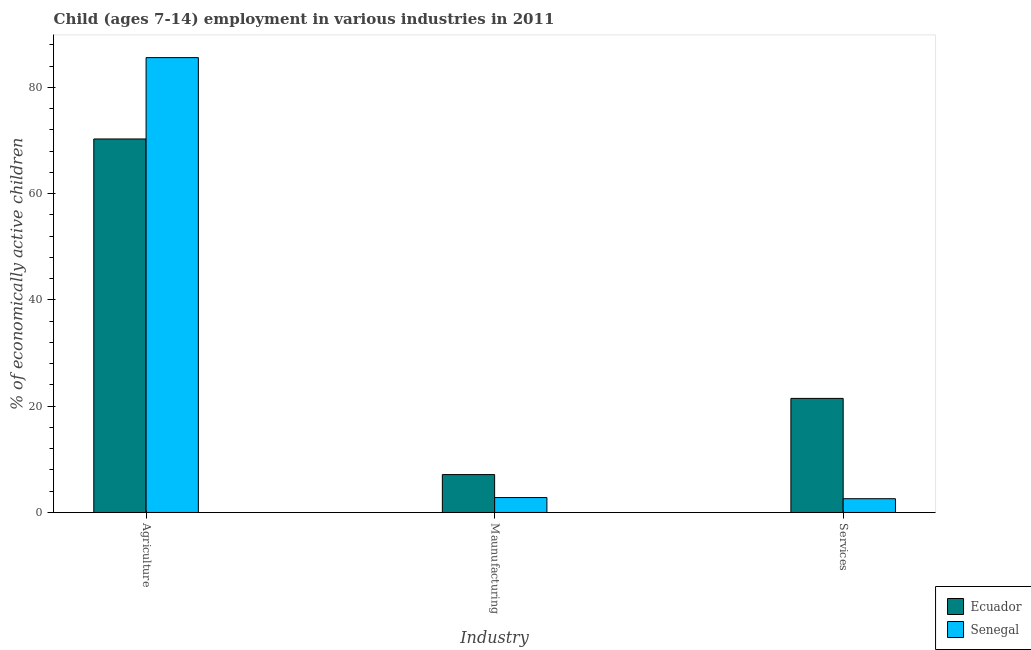How many different coloured bars are there?
Offer a very short reply. 2. Are the number of bars per tick equal to the number of legend labels?
Offer a terse response. Yes. Are the number of bars on each tick of the X-axis equal?
Give a very brief answer. Yes. How many bars are there on the 3rd tick from the right?
Offer a very short reply. 2. What is the label of the 1st group of bars from the left?
Provide a succinct answer. Agriculture. What is the percentage of economically active children in services in Senegal?
Offer a terse response. 2.59. Across all countries, what is the maximum percentage of economically active children in services?
Keep it short and to the point. 21.47. Across all countries, what is the minimum percentage of economically active children in services?
Offer a very short reply. 2.59. In which country was the percentage of economically active children in manufacturing maximum?
Make the answer very short. Ecuador. In which country was the percentage of economically active children in services minimum?
Provide a succinct answer. Senegal. What is the total percentage of economically active children in manufacturing in the graph?
Your response must be concise. 9.94. What is the difference between the percentage of economically active children in services in Ecuador and that in Senegal?
Offer a terse response. 18.88. What is the difference between the percentage of economically active children in agriculture in Ecuador and the percentage of economically active children in manufacturing in Senegal?
Offer a very short reply. 67.48. What is the average percentage of economically active children in services per country?
Offer a very short reply. 12.03. What is the difference between the percentage of economically active children in services and percentage of economically active children in agriculture in Ecuador?
Offer a terse response. -48.82. In how many countries, is the percentage of economically active children in services greater than 56 %?
Offer a very short reply. 0. What is the ratio of the percentage of economically active children in services in Senegal to that in Ecuador?
Your response must be concise. 0.12. What is the difference between the highest and the second highest percentage of economically active children in services?
Ensure brevity in your answer.  18.88. What is the difference between the highest and the lowest percentage of economically active children in services?
Provide a short and direct response. 18.88. In how many countries, is the percentage of economically active children in services greater than the average percentage of economically active children in services taken over all countries?
Your response must be concise. 1. What does the 2nd bar from the left in Services represents?
Ensure brevity in your answer.  Senegal. What does the 1st bar from the right in Services represents?
Provide a short and direct response. Senegal. How many bars are there?
Offer a terse response. 6. Are all the bars in the graph horizontal?
Your answer should be very brief. No. How many countries are there in the graph?
Your answer should be compact. 2. Are the values on the major ticks of Y-axis written in scientific E-notation?
Provide a short and direct response. No. Does the graph contain any zero values?
Keep it short and to the point. No. Where does the legend appear in the graph?
Your answer should be very brief. Bottom right. How many legend labels are there?
Give a very brief answer. 2. How are the legend labels stacked?
Provide a short and direct response. Vertical. What is the title of the graph?
Provide a succinct answer. Child (ages 7-14) employment in various industries in 2011. What is the label or title of the X-axis?
Ensure brevity in your answer.  Industry. What is the label or title of the Y-axis?
Provide a succinct answer. % of economically active children. What is the % of economically active children in Ecuador in Agriculture?
Provide a succinct answer. 70.29. What is the % of economically active children of Senegal in Agriculture?
Give a very brief answer. 85.6. What is the % of economically active children in Ecuador in Maunufacturing?
Your answer should be compact. 7.13. What is the % of economically active children in Senegal in Maunufacturing?
Give a very brief answer. 2.81. What is the % of economically active children of Ecuador in Services?
Keep it short and to the point. 21.47. What is the % of economically active children of Senegal in Services?
Offer a terse response. 2.59. Across all Industry, what is the maximum % of economically active children in Ecuador?
Your answer should be compact. 70.29. Across all Industry, what is the maximum % of economically active children of Senegal?
Your answer should be very brief. 85.6. Across all Industry, what is the minimum % of economically active children of Ecuador?
Your response must be concise. 7.13. Across all Industry, what is the minimum % of economically active children in Senegal?
Make the answer very short. 2.59. What is the total % of economically active children in Ecuador in the graph?
Provide a succinct answer. 98.89. What is the total % of economically active children in Senegal in the graph?
Your answer should be very brief. 91. What is the difference between the % of economically active children in Ecuador in Agriculture and that in Maunufacturing?
Provide a short and direct response. 63.16. What is the difference between the % of economically active children in Senegal in Agriculture and that in Maunufacturing?
Offer a very short reply. 82.79. What is the difference between the % of economically active children in Ecuador in Agriculture and that in Services?
Provide a succinct answer. 48.82. What is the difference between the % of economically active children of Senegal in Agriculture and that in Services?
Offer a very short reply. 83.01. What is the difference between the % of economically active children in Ecuador in Maunufacturing and that in Services?
Offer a terse response. -14.34. What is the difference between the % of economically active children in Senegal in Maunufacturing and that in Services?
Offer a very short reply. 0.22. What is the difference between the % of economically active children in Ecuador in Agriculture and the % of economically active children in Senegal in Maunufacturing?
Offer a very short reply. 67.48. What is the difference between the % of economically active children of Ecuador in Agriculture and the % of economically active children of Senegal in Services?
Give a very brief answer. 67.7. What is the difference between the % of economically active children of Ecuador in Maunufacturing and the % of economically active children of Senegal in Services?
Give a very brief answer. 4.54. What is the average % of economically active children in Ecuador per Industry?
Keep it short and to the point. 32.96. What is the average % of economically active children of Senegal per Industry?
Provide a short and direct response. 30.33. What is the difference between the % of economically active children in Ecuador and % of economically active children in Senegal in Agriculture?
Provide a short and direct response. -15.31. What is the difference between the % of economically active children of Ecuador and % of economically active children of Senegal in Maunufacturing?
Give a very brief answer. 4.32. What is the difference between the % of economically active children in Ecuador and % of economically active children in Senegal in Services?
Provide a short and direct response. 18.88. What is the ratio of the % of economically active children of Ecuador in Agriculture to that in Maunufacturing?
Keep it short and to the point. 9.86. What is the ratio of the % of economically active children in Senegal in Agriculture to that in Maunufacturing?
Your answer should be compact. 30.46. What is the ratio of the % of economically active children of Ecuador in Agriculture to that in Services?
Provide a succinct answer. 3.27. What is the ratio of the % of economically active children of Senegal in Agriculture to that in Services?
Your answer should be very brief. 33.05. What is the ratio of the % of economically active children in Ecuador in Maunufacturing to that in Services?
Your answer should be very brief. 0.33. What is the ratio of the % of economically active children of Senegal in Maunufacturing to that in Services?
Your answer should be very brief. 1.08. What is the difference between the highest and the second highest % of economically active children of Ecuador?
Your response must be concise. 48.82. What is the difference between the highest and the second highest % of economically active children in Senegal?
Offer a very short reply. 82.79. What is the difference between the highest and the lowest % of economically active children of Ecuador?
Make the answer very short. 63.16. What is the difference between the highest and the lowest % of economically active children in Senegal?
Ensure brevity in your answer.  83.01. 